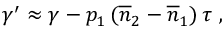Convert formula to latex. <formula><loc_0><loc_0><loc_500><loc_500>\gamma ^ { \prime } \approx \gamma - p _ { 1 } \left ( \overline { n } _ { 2 } - \overline { n } _ { 1 } \right ) \tau \ ,</formula> 